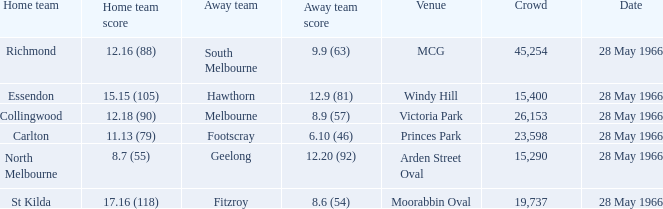Which Crowd has an Away team score of 8.6 (54)? 19737.0. 